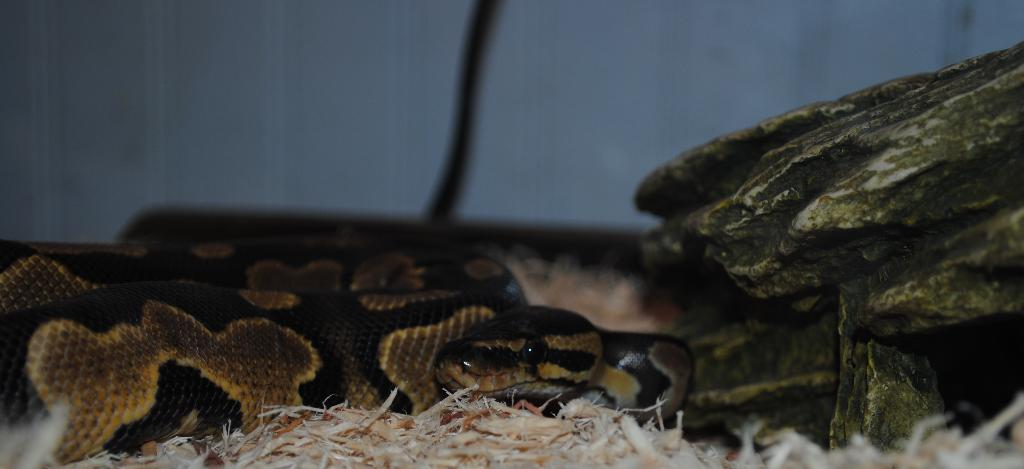What animal can be seen on the path in the image? There is a snake on the path in the image. What is located on the right side of the snake? There is a rock on the right side of the snake. What is visible behind the snake? There is a wall behind the snake. What type of whistle can be heard coming from the snake in the image? There is no whistle present in the image, as snakes do not produce whistling sounds. 